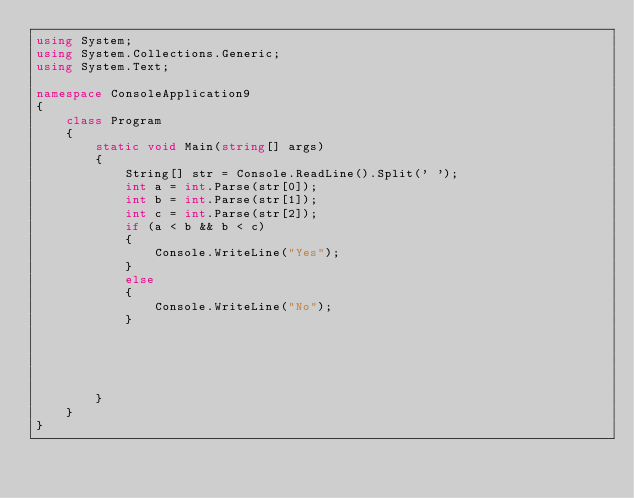Convert code to text. <code><loc_0><loc_0><loc_500><loc_500><_C#_>using System;
using System.Collections.Generic;
using System.Text;

namespace ConsoleApplication9
{
    class Program
    {
        static void Main(string[] args)
        {
            String[] str = Console.ReadLine().Split(' ');
            int a = int.Parse(str[0]);
            int b = int.Parse(str[1]);
            int c = int.Parse(str[2]);
            if (a < b && b < c)
            {
                Console.WriteLine("Yes");
            }
            else
            {
                Console.WriteLine("No");
            }

            
           
         

        }
    }
}</code> 